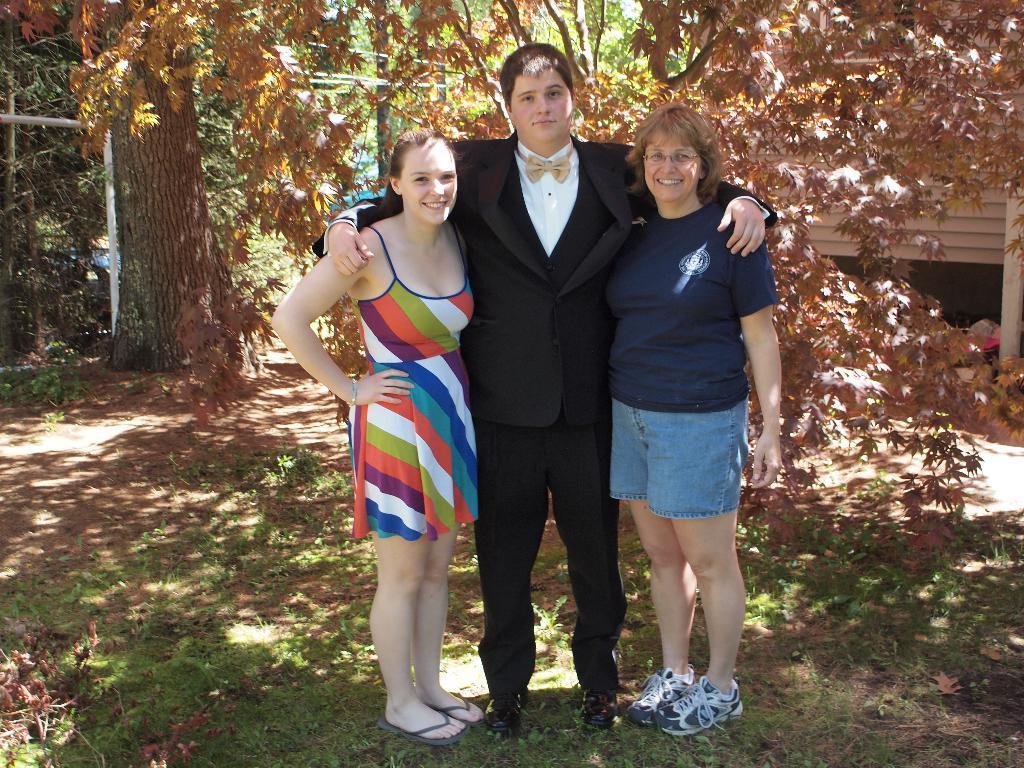How would you summarize this image in a sentence or two? In the center of the image there are three people. At the bottom of the image there is grass on the surface. In the background of the image there are trees, building. 